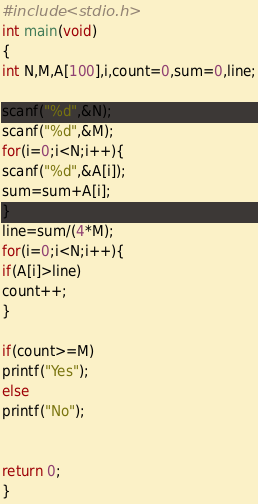Convert code to text. <code><loc_0><loc_0><loc_500><loc_500><_C_>#include <stdio.h>
int main(void)
{
int N,M,A[100],i,count=0,sum=0,line;

scanf("%d",&N);
scanf("%d",&M);
for(i=0;i<N;i++){
scanf("%d",&A[i]);
sum=sum+A[i];
}
line=sum/(4*M);
for(i=0;i<N;i++){
if(A[i]>line)
count++;
}

if(count>=M)
printf("Yes");
else
printf("No");


return 0;
}</code> 